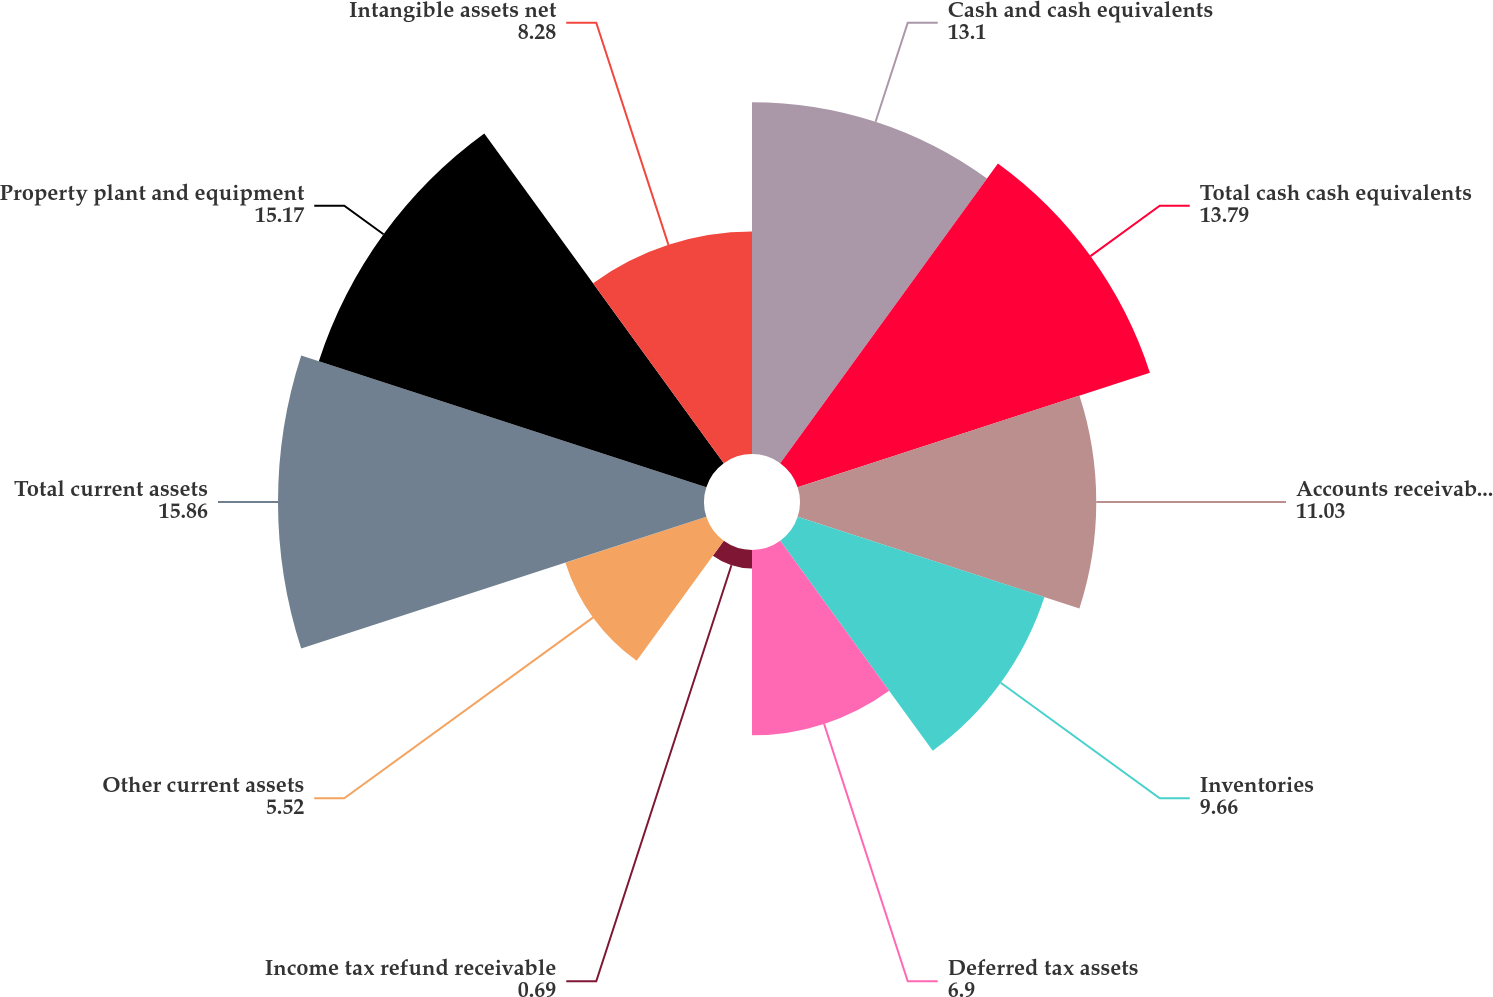<chart> <loc_0><loc_0><loc_500><loc_500><pie_chart><fcel>Cash and cash equivalents<fcel>Total cash cash equivalents<fcel>Accounts receivable net of<fcel>Inventories<fcel>Deferred tax assets<fcel>Income tax refund receivable<fcel>Other current assets<fcel>Total current assets<fcel>Property plant and equipment<fcel>Intangible assets net<nl><fcel>13.1%<fcel>13.79%<fcel>11.03%<fcel>9.66%<fcel>6.9%<fcel>0.69%<fcel>5.52%<fcel>15.86%<fcel>15.17%<fcel>8.28%<nl></chart> 